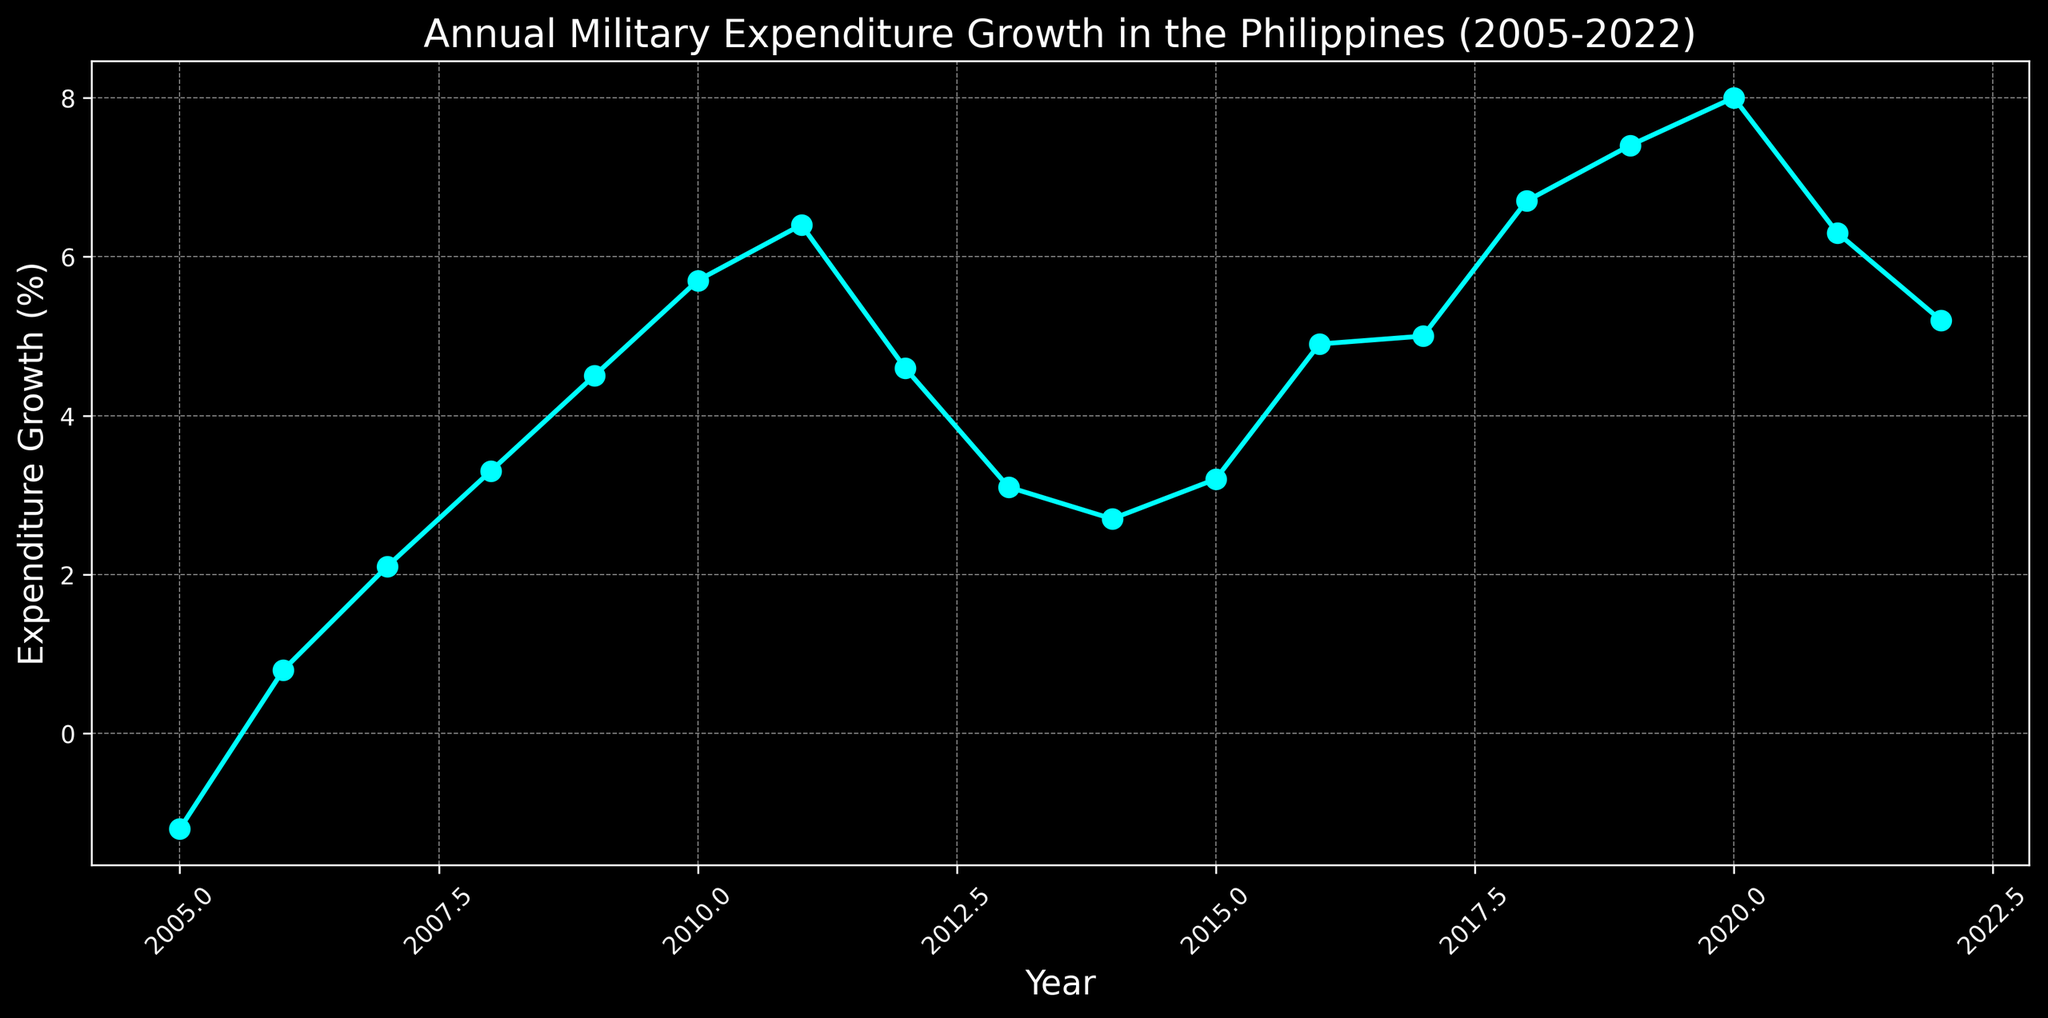How did the military expenditure growth rate change from 2005 to 2022? The military expenditure growth rate started at -1.2% in 2005 and ended at 5.2% in 2022. This shows an overall increase.
Answer: It increased What is the highest military expenditure growth rate recorded in the given period? The highest growth rate can be observed by looking at the peak point in the line chart, which is 8.0% in 2020.
Answer: 8.0% In which year did the military expenditure growth rate first exceed 5%? By examining the plot, we can see that the first time the growth rate exceeded 5% was in 2010, where it reached 5.7%.
Answer: 2010 Compared to 2008, how much higher was the growth in military expenditure in 2018? The growth in 2008 was 3.3%, and in 2018 it was 6.7%. Therefore, it was 6.7% - 3.3% = 3.4% higher in 2018.
Answer: 3.4% Which years showed a decrease in military expenditure growth compared to the previous year? We need to identify the years where the line graph goes down. These years are 2012, 2013, 2014, 2021, and 2022.
Answer: 2012, 2013, 2014, 2021, 2022 How many years had a military expenditure growth rate above 4%? By reading the y-values on the graph, the years with growth rates above 4% are 2009, 2010, 2011, 2012, 2016, 2017, 2018, 2019, 2020, and 2021. There are 10 such years.
Answer: 10 years What is the average military expenditure growth rate from 2015 to 2020? The growth rates for these years are 3.2, 4.9, 5.0, 6.7, 7.4, and 8.0. Summing these gives 35.2, and there are 6 data points, so the average is 35.2/6 = 5.87%.
Answer: 5.87% Which year experienced the largest single-year increase in military expenditure growth rate, and what was the increase? The largest increase can be found by examining the steepest upward segment in the graph. The increase from 2017 (5.0%) to 2018 (6.7%) is 1.7%, making it the largest.
Answer: 2018, 1.7% What color is the line used to represent the military expenditure growth in the chart? According to the visual attributes, the line color used in the chart is cyan.
Answer: Cyan 